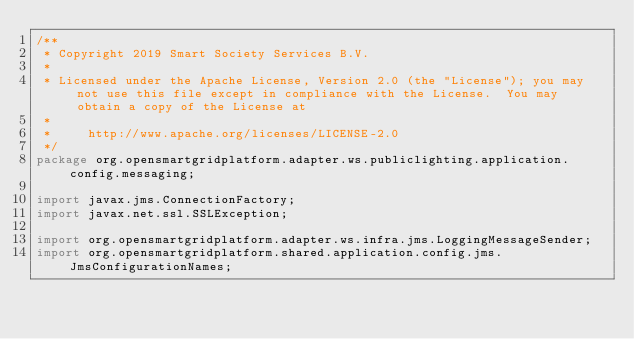Convert code to text. <code><loc_0><loc_0><loc_500><loc_500><_Java_>/**
 * Copyright 2019 Smart Society Services B.V.
 *
 * Licensed under the Apache License, Version 2.0 (the "License"); you may not use this file except in compliance with the License.  You may obtain a copy of the License at
 *
 *     http://www.apache.org/licenses/LICENSE-2.0
 */
package org.opensmartgridplatform.adapter.ws.publiclighting.application.config.messaging;

import javax.jms.ConnectionFactory;
import javax.net.ssl.SSLException;

import org.opensmartgridplatform.adapter.ws.infra.jms.LoggingMessageSender;
import org.opensmartgridplatform.shared.application.config.jms.JmsConfigurationNames;</code> 